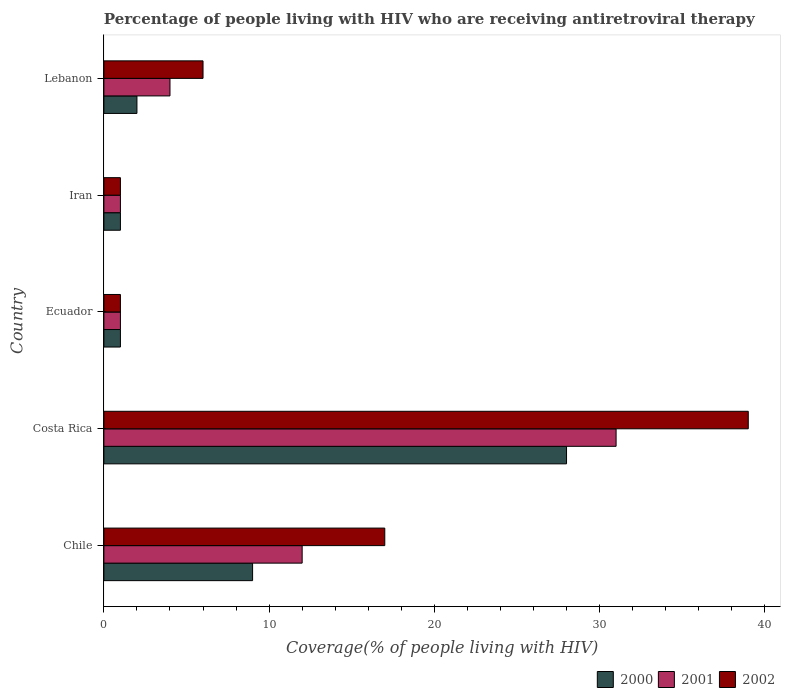How many different coloured bars are there?
Ensure brevity in your answer.  3. Are the number of bars on each tick of the Y-axis equal?
Make the answer very short. Yes. What is the label of the 2nd group of bars from the top?
Offer a terse response. Iran. What is the percentage of the HIV infected people who are receiving antiretroviral therapy in 2000 in Lebanon?
Your answer should be compact. 2. Across all countries, what is the maximum percentage of the HIV infected people who are receiving antiretroviral therapy in 2000?
Ensure brevity in your answer.  28. In which country was the percentage of the HIV infected people who are receiving antiretroviral therapy in 2001 minimum?
Ensure brevity in your answer.  Ecuador. What is the total percentage of the HIV infected people who are receiving antiretroviral therapy in 2001 in the graph?
Offer a very short reply. 49. What is the difference between the percentage of the HIV infected people who are receiving antiretroviral therapy in 2000 in Iran and that in Lebanon?
Your answer should be compact. -1. What is the difference between the percentage of the HIV infected people who are receiving antiretroviral therapy in 2002 in Lebanon and the percentage of the HIV infected people who are receiving antiretroviral therapy in 2001 in Costa Rica?
Provide a short and direct response. -25. What is the ratio of the percentage of the HIV infected people who are receiving antiretroviral therapy in 2002 in Chile to that in Iran?
Offer a very short reply. 17. Is the percentage of the HIV infected people who are receiving antiretroviral therapy in 2000 in Chile less than that in Ecuador?
Offer a terse response. No. What is the difference between the highest and the second highest percentage of the HIV infected people who are receiving antiretroviral therapy in 2000?
Offer a very short reply. 19. What is the difference between the highest and the lowest percentage of the HIV infected people who are receiving antiretroviral therapy in 2001?
Provide a succinct answer. 30. What does the 2nd bar from the top in Chile represents?
Keep it short and to the point. 2001. Is it the case that in every country, the sum of the percentage of the HIV infected people who are receiving antiretroviral therapy in 2002 and percentage of the HIV infected people who are receiving antiretroviral therapy in 2000 is greater than the percentage of the HIV infected people who are receiving antiretroviral therapy in 2001?
Offer a terse response. Yes. How many bars are there?
Provide a short and direct response. 15. Are all the bars in the graph horizontal?
Provide a short and direct response. Yes. How many countries are there in the graph?
Offer a very short reply. 5. What is the difference between two consecutive major ticks on the X-axis?
Make the answer very short. 10. Does the graph contain any zero values?
Keep it short and to the point. No. Does the graph contain grids?
Make the answer very short. No. How are the legend labels stacked?
Offer a terse response. Horizontal. What is the title of the graph?
Make the answer very short. Percentage of people living with HIV who are receiving antiretroviral therapy. What is the label or title of the X-axis?
Your answer should be very brief. Coverage(% of people living with HIV). What is the Coverage(% of people living with HIV) in 2000 in Chile?
Provide a succinct answer. 9. What is the Coverage(% of people living with HIV) of 2001 in Chile?
Your answer should be very brief. 12. What is the Coverage(% of people living with HIV) in 2002 in Chile?
Offer a terse response. 17. What is the Coverage(% of people living with HIV) of 2001 in Ecuador?
Ensure brevity in your answer.  1. What is the Coverage(% of people living with HIV) in 2002 in Iran?
Offer a terse response. 1. What is the Coverage(% of people living with HIV) of 2000 in Lebanon?
Give a very brief answer. 2. Across all countries, what is the maximum Coverage(% of people living with HIV) of 2000?
Offer a terse response. 28. Across all countries, what is the maximum Coverage(% of people living with HIV) of 2001?
Keep it short and to the point. 31. Across all countries, what is the minimum Coverage(% of people living with HIV) in 2000?
Make the answer very short. 1. Across all countries, what is the minimum Coverage(% of people living with HIV) in 2001?
Keep it short and to the point. 1. What is the total Coverage(% of people living with HIV) of 2001 in the graph?
Provide a succinct answer. 49. What is the total Coverage(% of people living with HIV) of 2002 in the graph?
Ensure brevity in your answer.  64. What is the difference between the Coverage(% of people living with HIV) of 2000 in Chile and that in Costa Rica?
Provide a succinct answer. -19. What is the difference between the Coverage(% of people living with HIV) of 2000 in Chile and that in Iran?
Make the answer very short. 8. What is the difference between the Coverage(% of people living with HIV) of 2000 in Costa Rica and that in Ecuador?
Make the answer very short. 27. What is the difference between the Coverage(% of people living with HIV) in 2001 in Costa Rica and that in Ecuador?
Make the answer very short. 30. What is the difference between the Coverage(% of people living with HIV) of 2001 in Costa Rica and that in Iran?
Provide a succinct answer. 30. What is the difference between the Coverage(% of people living with HIV) in 2000 in Costa Rica and that in Lebanon?
Offer a terse response. 26. What is the difference between the Coverage(% of people living with HIV) in 2001 in Costa Rica and that in Lebanon?
Your answer should be very brief. 27. What is the difference between the Coverage(% of people living with HIV) of 2001 in Ecuador and that in Iran?
Your response must be concise. 0. What is the difference between the Coverage(% of people living with HIV) in 2000 in Ecuador and that in Lebanon?
Ensure brevity in your answer.  -1. What is the difference between the Coverage(% of people living with HIV) of 2000 in Iran and that in Lebanon?
Your answer should be very brief. -1. What is the difference between the Coverage(% of people living with HIV) of 2001 in Iran and that in Lebanon?
Your answer should be very brief. -3. What is the difference between the Coverage(% of people living with HIV) of 2002 in Iran and that in Lebanon?
Your answer should be very brief. -5. What is the difference between the Coverage(% of people living with HIV) in 2000 in Chile and the Coverage(% of people living with HIV) in 2001 in Costa Rica?
Your answer should be compact. -22. What is the difference between the Coverage(% of people living with HIV) in 2000 in Chile and the Coverage(% of people living with HIV) in 2002 in Costa Rica?
Your answer should be very brief. -30. What is the difference between the Coverage(% of people living with HIV) in 2001 in Chile and the Coverage(% of people living with HIV) in 2002 in Costa Rica?
Offer a very short reply. -27. What is the difference between the Coverage(% of people living with HIV) in 2000 in Chile and the Coverage(% of people living with HIV) in 2001 in Ecuador?
Keep it short and to the point. 8. What is the difference between the Coverage(% of people living with HIV) of 2000 in Chile and the Coverage(% of people living with HIV) of 2002 in Ecuador?
Offer a terse response. 8. What is the difference between the Coverage(% of people living with HIV) in 2001 in Chile and the Coverage(% of people living with HIV) in 2002 in Ecuador?
Your answer should be compact. 11. What is the difference between the Coverage(% of people living with HIV) of 2001 in Chile and the Coverage(% of people living with HIV) of 2002 in Iran?
Ensure brevity in your answer.  11. What is the difference between the Coverage(% of people living with HIV) in 2000 in Chile and the Coverage(% of people living with HIV) in 2001 in Lebanon?
Provide a short and direct response. 5. What is the difference between the Coverage(% of people living with HIV) in 2000 in Chile and the Coverage(% of people living with HIV) in 2002 in Lebanon?
Keep it short and to the point. 3. What is the difference between the Coverage(% of people living with HIV) of 2001 in Chile and the Coverage(% of people living with HIV) of 2002 in Lebanon?
Your answer should be very brief. 6. What is the difference between the Coverage(% of people living with HIV) of 2000 in Costa Rica and the Coverage(% of people living with HIV) of 2001 in Ecuador?
Offer a terse response. 27. What is the difference between the Coverage(% of people living with HIV) in 2000 in Costa Rica and the Coverage(% of people living with HIV) in 2002 in Ecuador?
Keep it short and to the point. 27. What is the difference between the Coverage(% of people living with HIV) in 2000 in Costa Rica and the Coverage(% of people living with HIV) in 2002 in Iran?
Offer a terse response. 27. What is the difference between the Coverage(% of people living with HIV) in 2001 in Costa Rica and the Coverage(% of people living with HIV) in 2002 in Iran?
Your answer should be compact. 30. What is the difference between the Coverage(% of people living with HIV) in 2001 in Costa Rica and the Coverage(% of people living with HIV) in 2002 in Lebanon?
Give a very brief answer. 25. What is the difference between the Coverage(% of people living with HIV) of 2000 in Ecuador and the Coverage(% of people living with HIV) of 2001 in Iran?
Make the answer very short. 0. What is the difference between the Coverage(% of people living with HIV) of 2000 in Ecuador and the Coverage(% of people living with HIV) of 2002 in Lebanon?
Your response must be concise. -5. What is the difference between the Coverage(% of people living with HIV) in 2001 in Ecuador and the Coverage(% of people living with HIV) in 2002 in Lebanon?
Your answer should be compact. -5. What is the difference between the Coverage(% of people living with HIV) of 2000 in Iran and the Coverage(% of people living with HIV) of 2001 in Lebanon?
Provide a succinct answer. -3. What is the difference between the Coverage(% of people living with HIV) in 2000 in Iran and the Coverage(% of people living with HIV) in 2002 in Lebanon?
Your answer should be very brief. -5. What is the difference between the Coverage(% of people living with HIV) of 2001 in Iran and the Coverage(% of people living with HIV) of 2002 in Lebanon?
Your answer should be very brief. -5. What is the average Coverage(% of people living with HIV) of 2000 per country?
Offer a very short reply. 8.2. What is the average Coverage(% of people living with HIV) of 2002 per country?
Your answer should be compact. 12.8. What is the difference between the Coverage(% of people living with HIV) of 2000 and Coverage(% of people living with HIV) of 2001 in Chile?
Your answer should be very brief. -3. What is the difference between the Coverage(% of people living with HIV) of 2001 and Coverage(% of people living with HIV) of 2002 in Chile?
Ensure brevity in your answer.  -5. What is the difference between the Coverage(% of people living with HIV) of 2000 and Coverage(% of people living with HIV) of 2001 in Costa Rica?
Your response must be concise. -3. What is the difference between the Coverage(% of people living with HIV) of 2001 and Coverage(% of people living with HIV) of 2002 in Costa Rica?
Ensure brevity in your answer.  -8. What is the difference between the Coverage(% of people living with HIV) in 2001 and Coverage(% of people living with HIV) in 2002 in Ecuador?
Ensure brevity in your answer.  0. What is the difference between the Coverage(% of people living with HIV) of 2001 and Coverage(% of people living with HIV) of 2002 in Iran?
Offer a very short reply. 0. What is the difference between the Coverage(% of people living with HIV) of 2000 and Coverage(% of people living with HIV) of 2002 in Lebanon?
Offer a very short reply. -4. What is the difference between the Coverage(% of people living with HIV) in 2001 and Coverage(% of people living with HIV) in 2002 in Lebanon?
Keep it short and to the point. -2. What is the ratio of the Coverage(% of people living with HIV) of 2000 in Chile to that in Costa Rica?
Your answer should be compact. 0.32. What is the ratio of the Coverage(% of people living with HIV) of 2001 in Chile to that in Costa Rica?
Offer a very short reply. 0.39. What is the ratio of the Coverage(% of people living with HIV) of 2002 in Chile to that in Costa Rica?
Give a very brief answer. 0.44. What is the ratio of the Coverage(% of people living with HIV) in 2000 in Chile to that in Ecuador?
Your answer should be very brief. 9. What is the ratio of the Coverage(% of people living with HIV) in 2002 in Chile to that in Ecuador?
Your response must be concise. 17. What is the ratio of the Coverage(% of people living with HIV) in 2002 in Chile to that in Lebanon?
Your answer should be compact. 2.83. What is the ratio of the Coverage(% of people living with HIV) of 2000 in Costa Rica to that in Ecuador?
Keep it short and to the point. 28. What is the ratio of the Coverage(% of people living with HIV) in 2001 in Costa Rica to that in Ecuador?
Give a very brief answer. 31. What is the ratio of the Coverage(% of people living with HIV) in 2002 in Costa Rica to that in Ecuador?
Your answer should be very brief. 39. What is the ratio of the Coverage(% of people living with HIV) in 2002 in Costa Rica to that in Iran?
Ensure brevity in your answer.  39. What is the ratio of the Coverage(% of people living with HIV) of 2001 in Costa Rica to that in Lebanon?
Offer a terse response. 7.75. What is the ratio of the Coverage(% of people living with HIV) in 2002 in Costa Rica to that in Lebanon?
Provide a short and direct response. 6.5. What is the ratio of the Coverage(% of people living with HIV) of 2000 in Ecuador to that in Iran?
Your answer should be compact. 1. What is the ratio of the Coverage(% of people living with HIV) in 2001 in Iran to that in Lebanon?
Give a very brief answer. 0.25. What is the difference between the highest and the second highest Coverage(% of people living with HIV) of 2001?
Your response must be concise. 19. What is the difference between the highest and the lowest Coverage(% of people living with HIV) in 2001?
Your answer should be very brief. 30. 